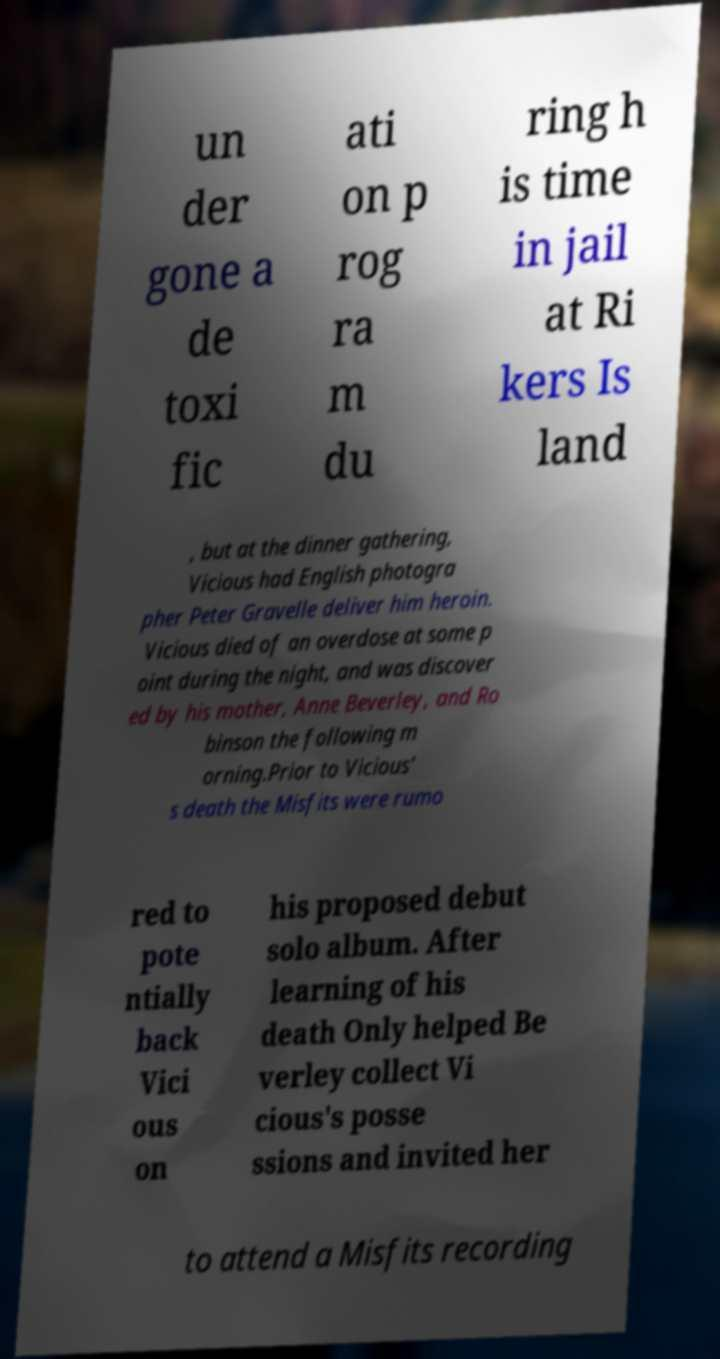I need the written content from this picture converted into text. Can you do that? un der gone a de toxi fic ati on p rog ra m du ring h is time in jail at Ri kers Is land , but at the dinner gathering, Vicious had English photogra pher Peter Gravelle deliver him heroin. Vicious died of an overdose at some p oint during the night, and was discover ed by his mother, Anne Beverley, and Ro binson the following m orning.Prior to Vicious' s death the Misfits were rumo red to pote ntially back Vici ous on his proposed debut solo album. After learning of his death Only helped Be verley collect Vi cious's posse ssions and invited her to attend a Misfits recording 